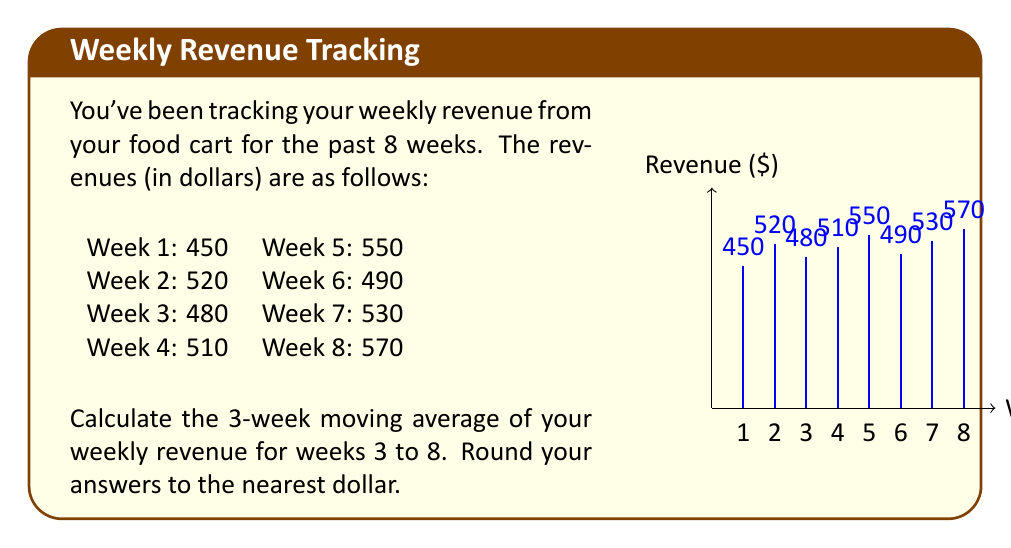Could you help me with this problem? To calculate the 3-week moving average, we need to follow these steps:

1) For each week from week 3 to week 8, we'll calculate the average of that week's revenue and the revenues of the two preceding weeks.

2) The formula for each 3-week moving average is:

   $$ MA_3 = \frac{Revenue_{week-2} + Revenue_{week-1} + Revenue_{week}}{3} $$

3) Let's calculate for each week:

   Week 3: $\frac{450 + 520 + 480}{3} = \frac{1450}{3} = 483.33$ ≈ $483$
   
   Week 4: $\frac{520 + 480 + 510}{3} = \frac{1510}{3} = 503.33$ ≈ $503$
   
   Week 5: $\frac{480 + 510 + 550}{3} = \frac{1540}{3} = 513.33$ ≈ $513$
   
   Week 6: $\frac{510 + 550 + 490}{3} = \frac{1550}{3} = 516.67$ ≈ $517$
   
   Week 7: $\frac{550 + 490 + 530}{3} = \frac{1570}{3} = 523.33$ ≈ $523$
   
   Week 8: $\frac{490 + 530 + 570}{3} = \frac{1590}{3} = 530$

4) Rounding to the nearest dollar gives us our final results.
Answer: $483, $503, $513, $517, $523, $530 